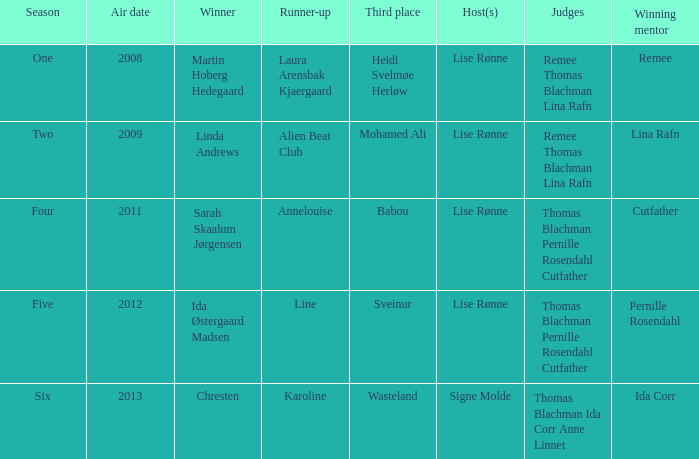Who won third place in season four? Babou. 